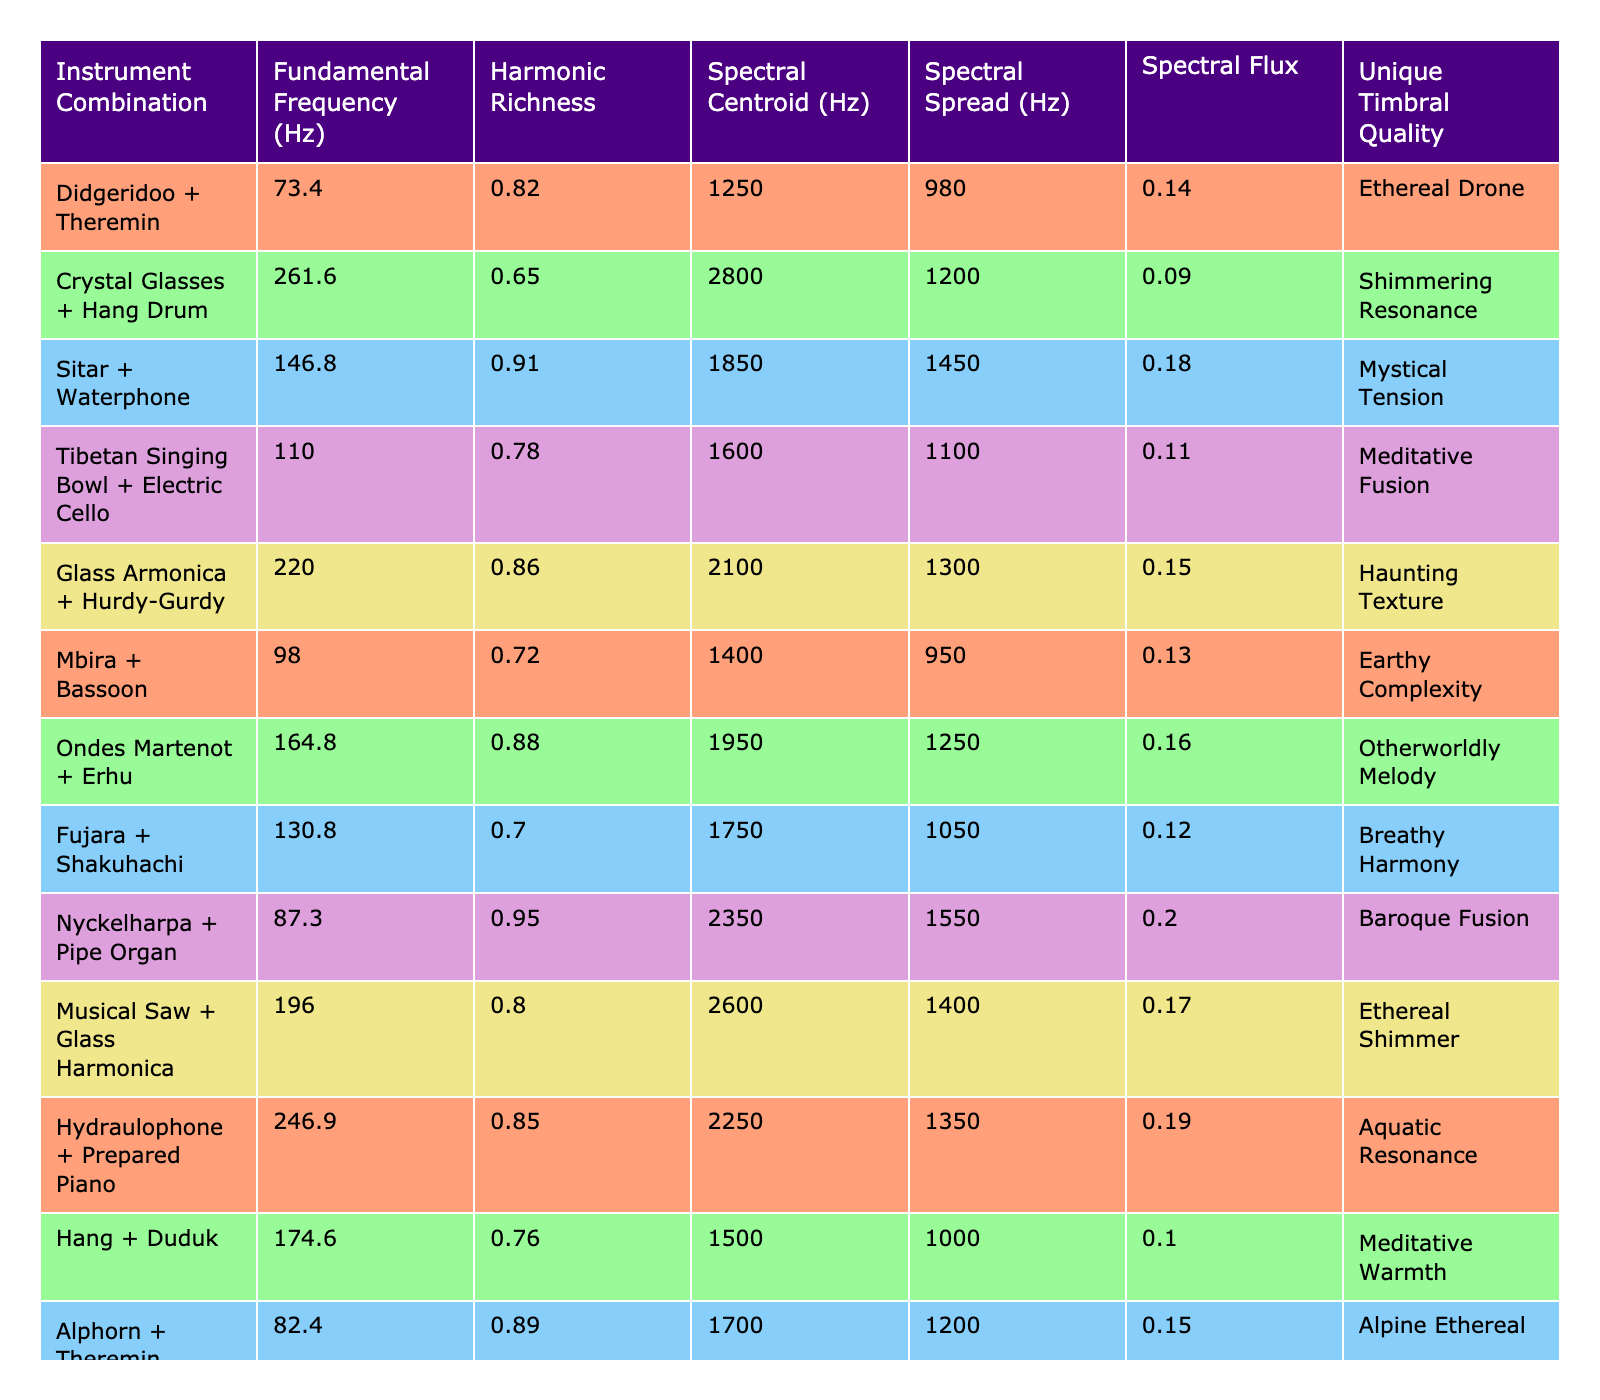What is the fundamental frequency of the Didgeridoo + Theremin combination? The table directly lists the fundamental frequency for the Didgeridoo + Theremin combination as 73.4 Hz.
Answer: 73.4 Hz Which instrument combination has the highest spectral flux? By examining the spectral flux values in the table, the Hydraulophone + Prepared Piano combination has the highest value at 0.19.
Answer: Hydraulophone + Prepared Piano Is the Sitar + Waterphone combination more harmonically rich than the Glass Armonica + Hurdy-Gurdy? The harmonic richness for the Sitar + Waterphone is 0.91, while the Glass Armonica + Hurdy-Gurdy has a harmonic richness of 0.86. Since 0.91 is greater than 0.86, the Sitar + Waterphone is indeed more harmonically rich.
Answer: Yes What is the average spectral centroid of all combinations? To find the average spectral centroid, sum all the values: (1250 + 2800 + 1850 + 1600 + 2100 + 1400 + 1950 + 1750 + 2350 + 2600 + 2250 + 1500 + 1700 + 2450 + 1300) = 23400, and then divide by the number of combinations (15), which gives 23400 / 15 = 1560.
Answer: 1560 Hz Are there more combinations with a unique timbral quality indicating "Ethereal" than "Meditative"? The table shows two combinations labeled "Ethereal" (Didgeridoo + Theremin and Musical Saw + Glass Harmonica) and two labeled "Meditative" (Tibetan Singing Bowl + Electric Cello and Hang + Duduk). Since both categories have two combinations, they are equal.
Answer: No Which combination has the lowest fundamental frequency? By checking the fundamental frequency values, the Overtone Singing + Didgeridoo combination has the lowest at 55.0 Hz.
Answer: 55.0 Hz Is the spectral spread of the Waterphone + Cristal Baschet greater than the spectral spread of the Ondes Martenot + Erhu? The spectral spread for Waterphone + Cristal Baschet is 1500 Hz, and for Ondes Martenot + Erhu, it is 1250 Hz. Since 1500 is greater than 1250, the statement is true.
Answer: Yes What is the difference in harmonic richness between Nyckelharpa + Pipe Organ and Mbira + Bassoon? The harmonic richness for Nyckelharpa + Pipe Organ is 0.95 while for Mbira + Bassoon it is 0.72. The difference is 0.95 - 0.72 = 0.23.
Answer: 0.23 What combination has a unique timbral quality described as "Crystalline Tension"? The combination with the unique timbral quality "Crystalline Tension" is Waterphone + Cristal Baschet, as indicated in the table.
Answer: Waterphone + Cristal Baschet How many combinations have a harmonic richness greater than 0.8? Checking the table, the combinations with a harmonic richness greater than 0.8 are Didgeridoo + Theremin, Sitar + Waterphone, Glass Armonica + Hurdy-Gurdy, Ondes Martenot + Erhu, Nyckelharpa + Pipe Organ, Waterphone + Cristal Baschet, and Overtone Singing + Didgeridoo. This gives a total of 7 combinations.
Answer: 7 